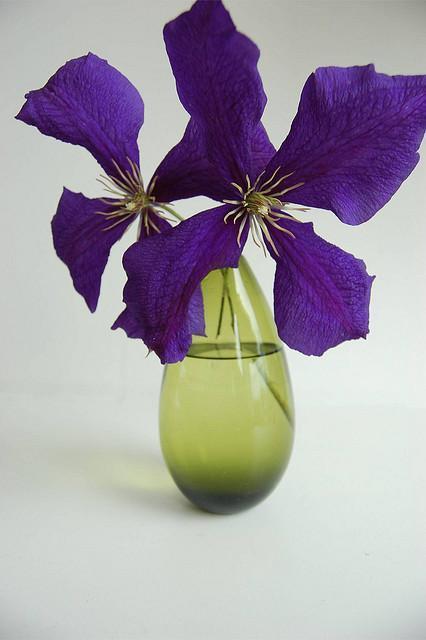How many men are standing up on their surfboards?
Give a very brief answer. 0. 